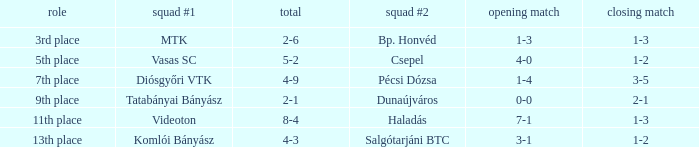How many positions correspond to a 1-3 1st leg? 1.0. 